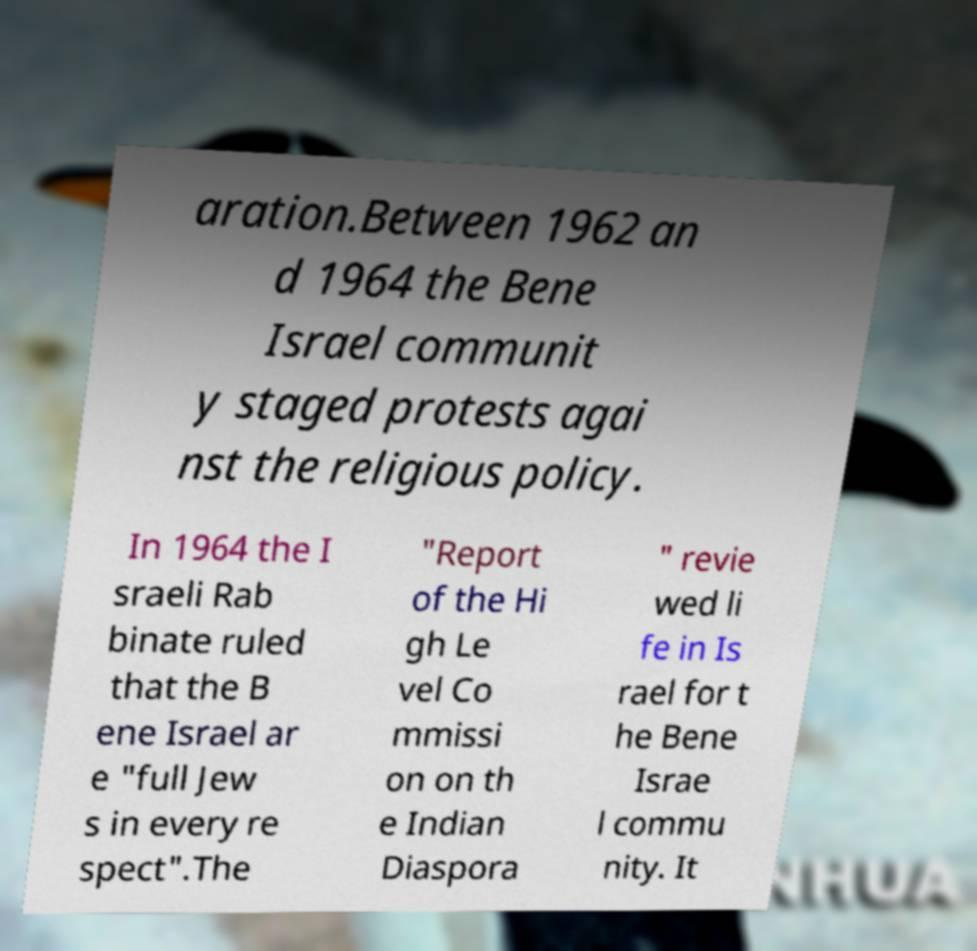Please read and relay the text visible in this image. What does it say? aration.Between 1962 an d 1964 the Bene Israel communit y staged protests agai nst the religious policy. In 1964 the I sraeli Rab binate ruled that the B ene Israel ar e "full Jew s in every re spect".The "Report of the Hi gh Le vel Co mmissi on on th e Indian Diaspora " revie wed li fe in Is rael for t he Bene Israe l commu nity. It 